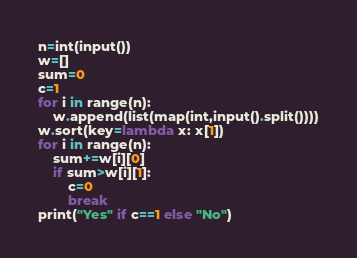<code> <loc_0><loc_0><loc_500><loc_500><_Python_>n=int(input())
w=[]
sum=0
c=1
for i in range(n):
    w.append(list(map(int,input().split())))
w.sort(key=lambda x: x[1])
for i in range(n):
    sum+=w[i][0]
    if sum>w[i][1]:
        c=0
        break
print("Yes" if c==1 else "No")</code> 